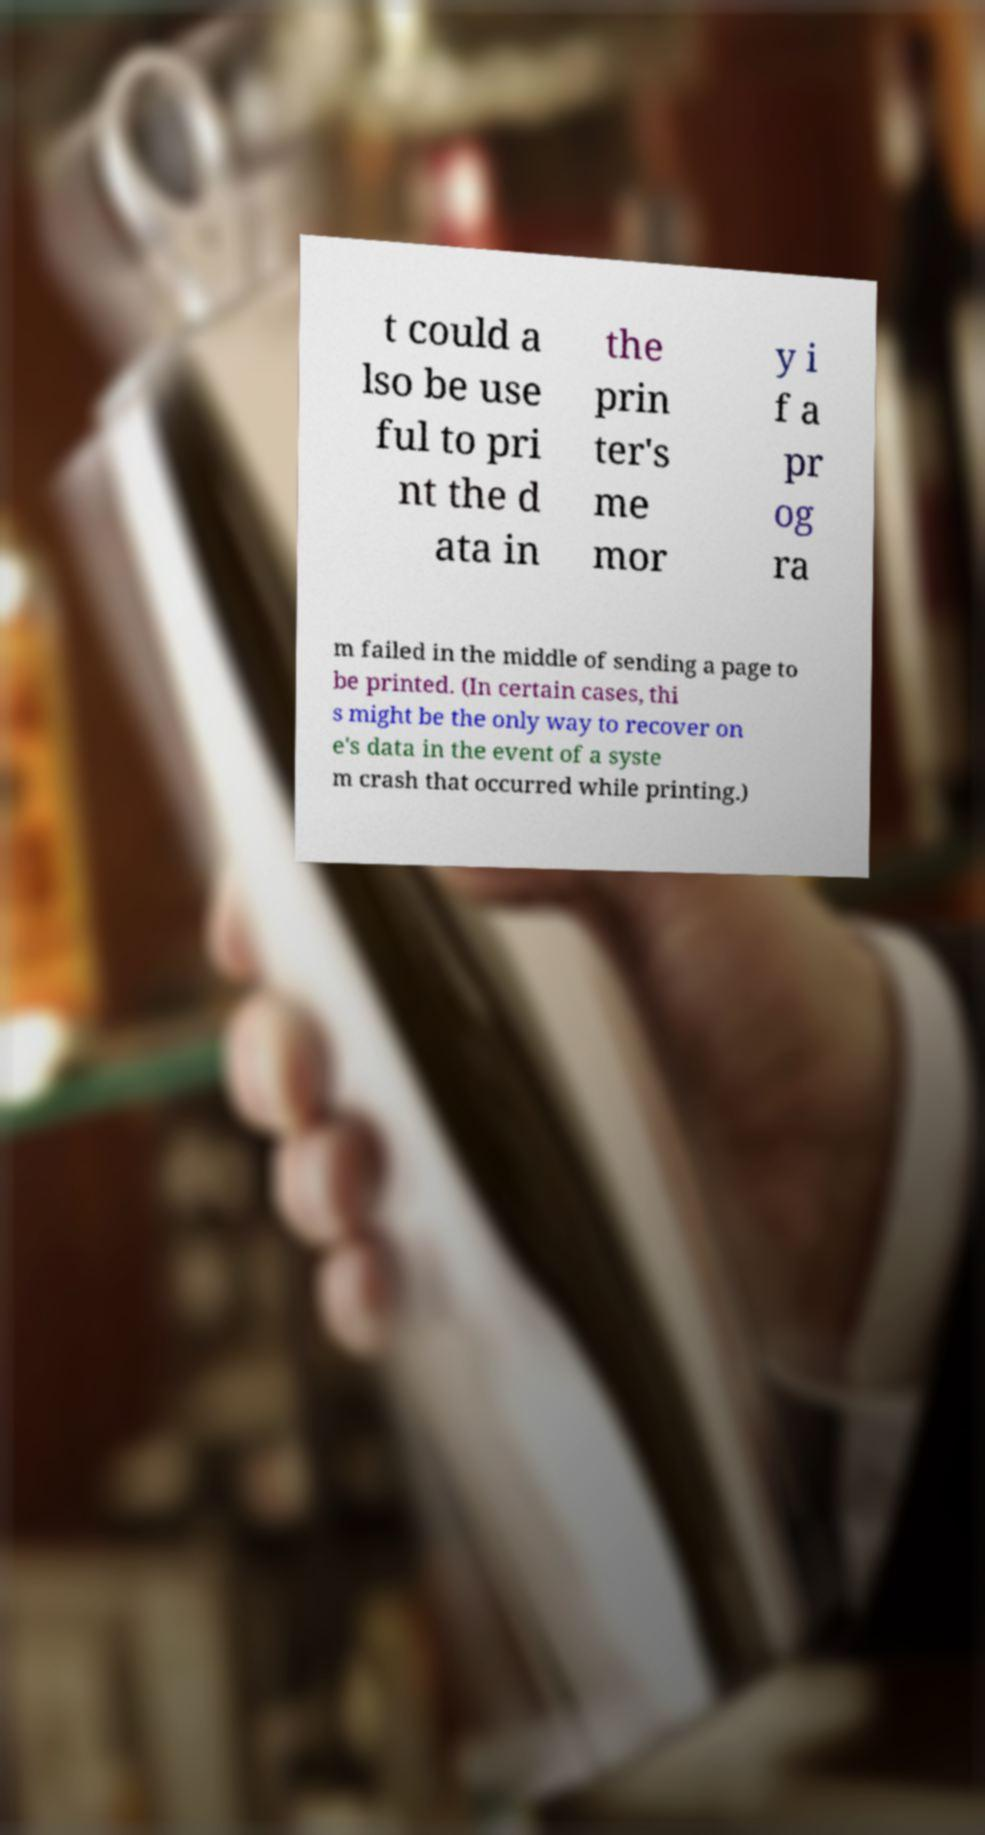Can you accurately transcribe the text from the provided image for me? t could a lso be use ful to pri nt the d ata in the prin ter's me mor y i f a pr og ra m failed in the middle of sending a page to be printed. (In certain cases, thi s might be the only way to recover on e's data in the event of a syste m crash that occurred while printing.) 